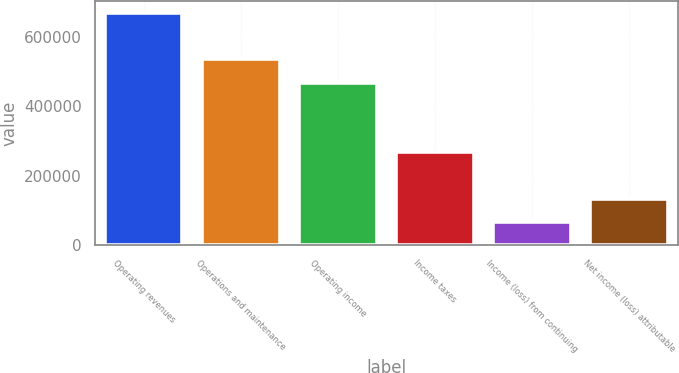Convert chart. <chart><loc_0><loc_0><loc_500><loc_500><bar_chart><fcel>Operating revenues<fcel>Operations and maintenance<fcel>Operating income<fcel>Income taxes<fcel>Income (loss) from continuing<fcel>Net income (loss) attributable<nl><fcel>667892<fcel>534314<fcel>467524<fcel>267157<fcel>66789.3<fcel>133578<nl></chart> 